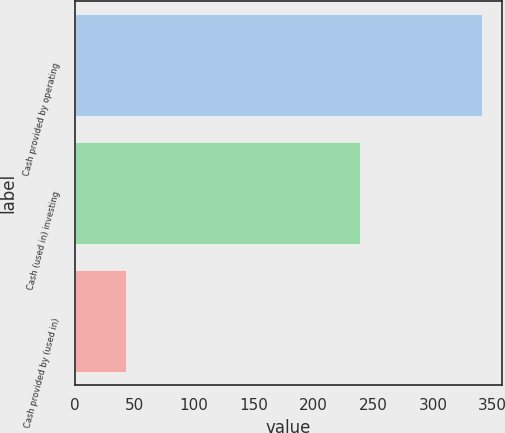Convert chart to OTSL. <chart><loc_0><loc_0><loc_500><loc_500><bar_chart><fcel>Cash provided by operating<fcel>Cash (used in) investing<fcel>Cash provided by (used in)<nl><fcel>341<fcel>238.7<fcel>43.1<nl></chart> 